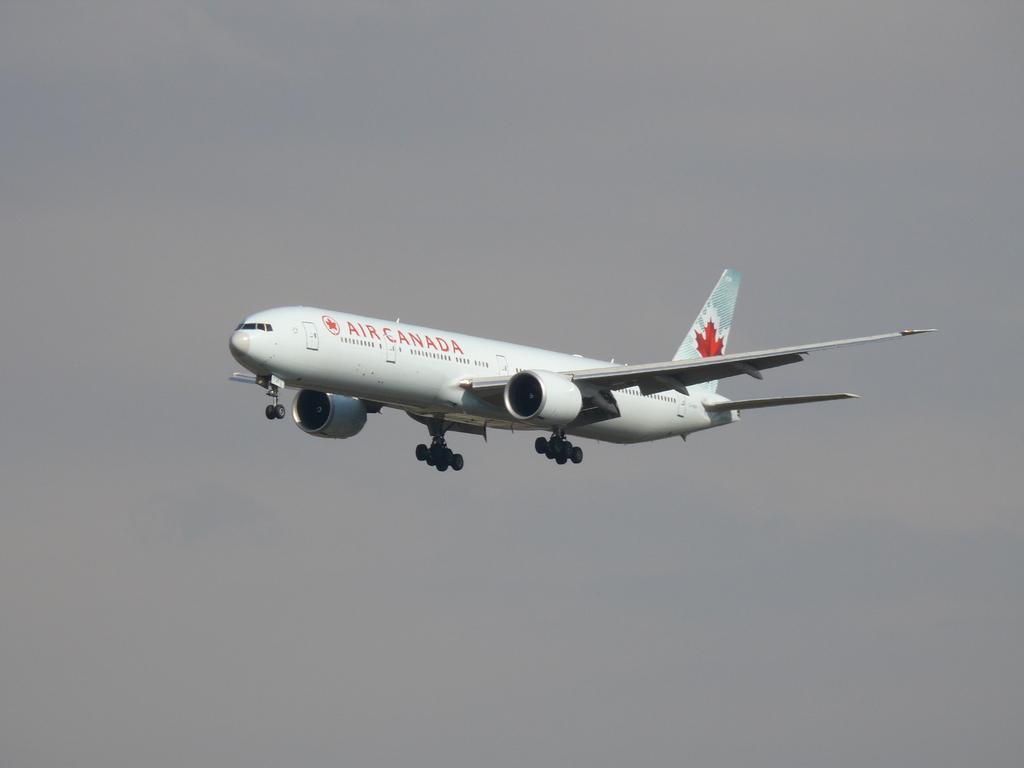Can you describe this image briefly? In this picture I can see there is a airplane flying and there is something written on it and there is a logo. The sky is cloudy. 